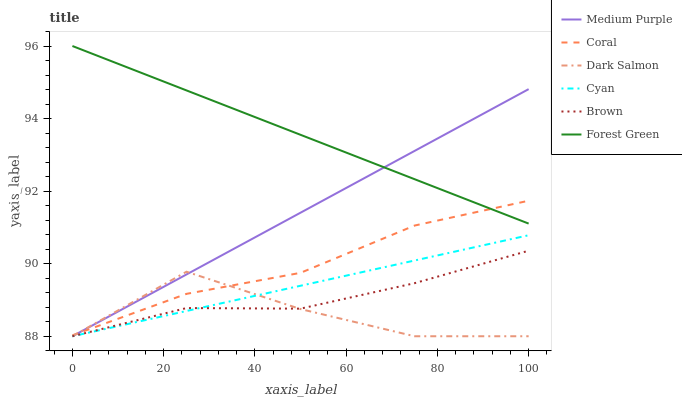Does Dark Salmon have the minimum area under the curve?
Answer yes or no. Yes. Does Forest Green have the maximum area under the curve?
Answer yes or no. Yes. Does Coral have the minimum area under the curve?
Answer yes or no. No. Does Coral have the maximum area under the curve?
Answer yes or no. No. Is Forest Green the smoothest?
Answer yes or no. Yes. Is Dark Salmon the roughest?
Answer yes or no. Yes. Is Coral the smoothest?
Answer yes or no. No. Is Coral the roughest?
Answer yes or no. No. Does Brown have the lowest value?
Answer yes or no. Yes. Does Coral have the lowest value?
Answer yes or no. No. Does Forest Green have the highest value?
Answer yes or no. Yes. Does Coral have the highest value?
Answer yes or no. No. Is Cyan less than Coral?
Answer yes or no. Yes. Is Coral greater than Brown?
Answer yes or no. Yes. Does Brown intersect Medium Purple?
Answer yes or no. Yes. Is Brown less than Medium Purple?
Answer yes or no. No. Is Brown greater than Medium Purple?
Answer yes or no. No. Does Cyan intersect Coral?
Answer yes or no. No. 